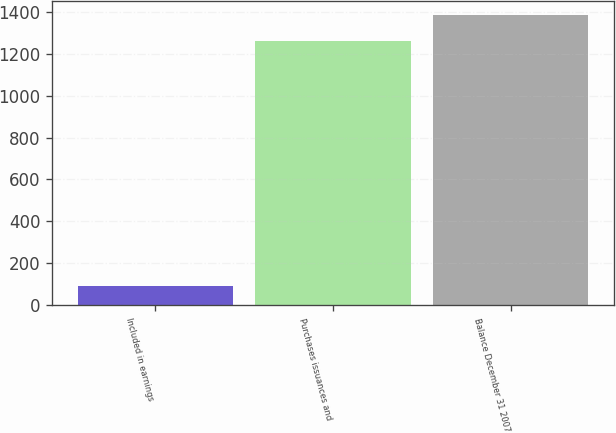Convert chart. <chart><loc_0><loc_0><loc_500><loc_500><bar_chart><fcel>Included in earnings<fcel>Purchases issuances and<fcel>Balance December 31 2007<nl><fcel>90<fcel>1259<fcel>1383.4<nl></chart> 